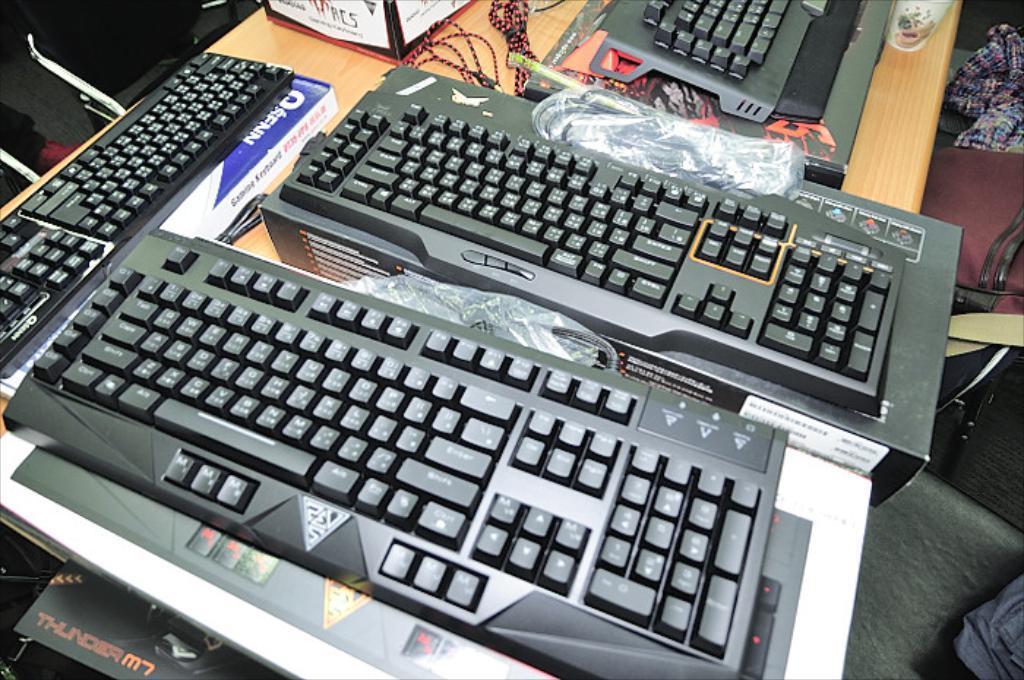Could you give a brief overview of what you see in this image? In this image, I can see the keyboards, cardboard boxes and few other things are placed on the table. On the right side of the image, I can see few objects. At the top left corner of the image, I think this is a chair. 